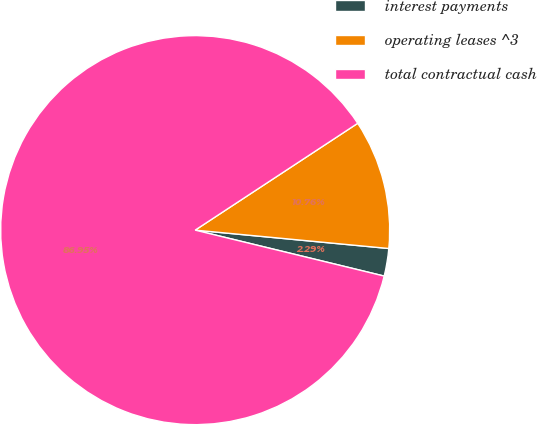Convert chart to OTSL. <chart><loc_0><loc_0><loc_500><loc_500><pie_chart><fcel>interest payments<fcel>operating leases ^3<fcel>total contractual cash<nl><fcel>2.29%<fcel>10.76%<fcel>86.95%<nl></chart> 